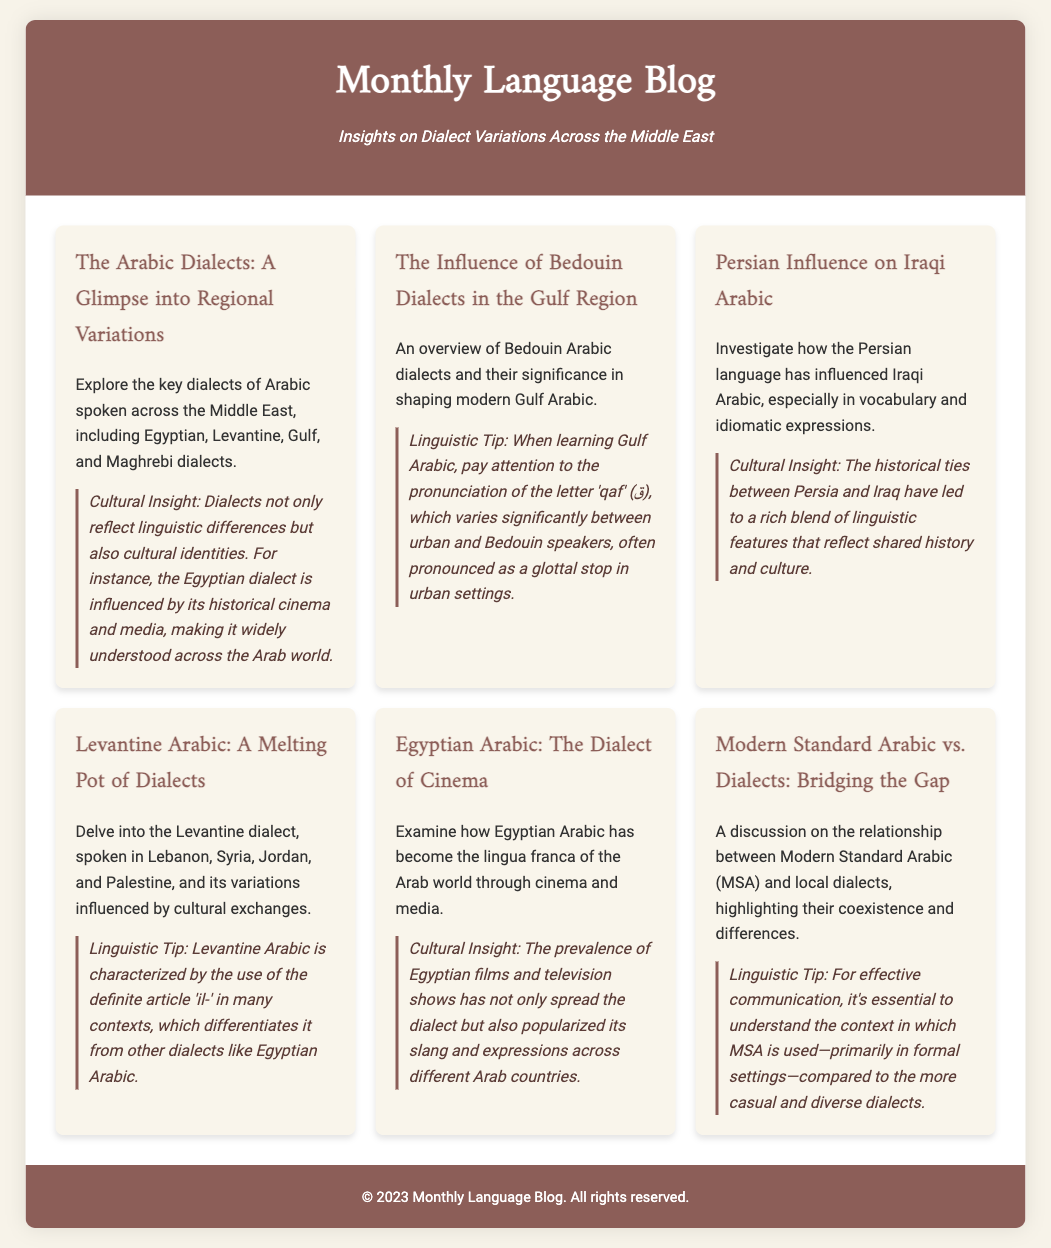What is the title of the blog? The title is prominently displayed in the header of the document.
Answer: Monthly Language Blog How many dialects are mentioned in the first card? The first card mentions key dialects including Egyptian, Levantine, Gulf, and Maghrebi dialects.
Answer: Four What is the main topic of the second card? The second card discusses Bedouin Arabic dialects and their significance.
Answer: Bedouin Dialects Which dialect is described as the lingua franca of the Arab world? The document states that Egyptian Arabic has become widely understood across the Arab world through cinema and media.
Answer: Egyptian Arabic What linguistic feature is highlighted for Gulf Arabic learners? The tip in the second card specifically mentions the pronunciation of the letter 'qaf'.
Answer: Pronunciation In which countries is Levantine Arabic spoken? The card discussing Levantine Arabic lists Lebanon, Syria, Jordan, and Palestine as the countries where it is spoken.
Answer: Lebanon, Syria, Jordan, Palestine What cultural aspect influences Egyptian Arabic? The document highlights the historical impact of cinema and media on the Egyptian dialect.
Answer: Cinema and media What characterizes the use of Modern Standard Arabic? The tip mentions that MSA is primarily used in formal settings.
Answer: Formal settings 